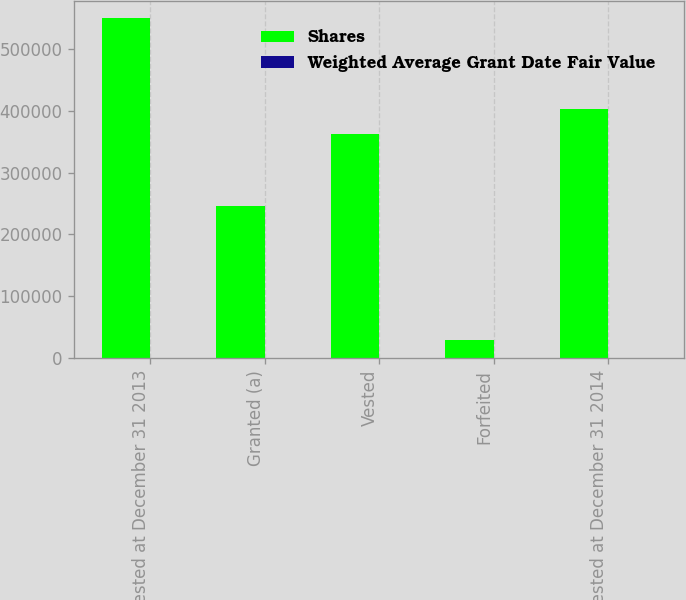Convert chart to OTSL. <chart><loc_0><loc_0><loc_500><loc_500><stacked_bar_chart><ecel><fcel>Unvested at December 31 2013<fcel>Granted (a)<fcel>Vested<fcel>Forfeited<fcel>Unvested at December 31 2014<nl><fcel>Shares<fcel>550000<fcel>246000<fcel>363000<fcel>30000<fcel>403000<nl><fcel>Weighted Average Grant Date Fair Value<fcel>128.04<fcel>395.22<fcel>107.89<fcel>192.85<fcel>219.29<nl></chart> 